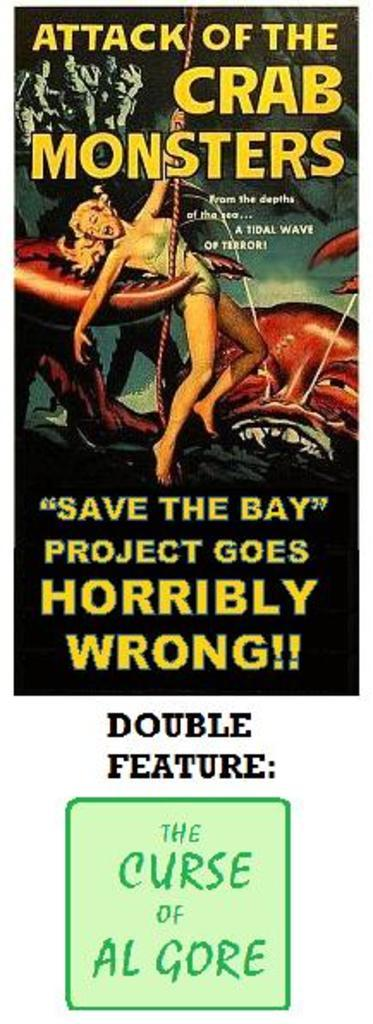<image>
Write a terse but informative summary of the picture. a poster that says 'the curse of al gore' on it 